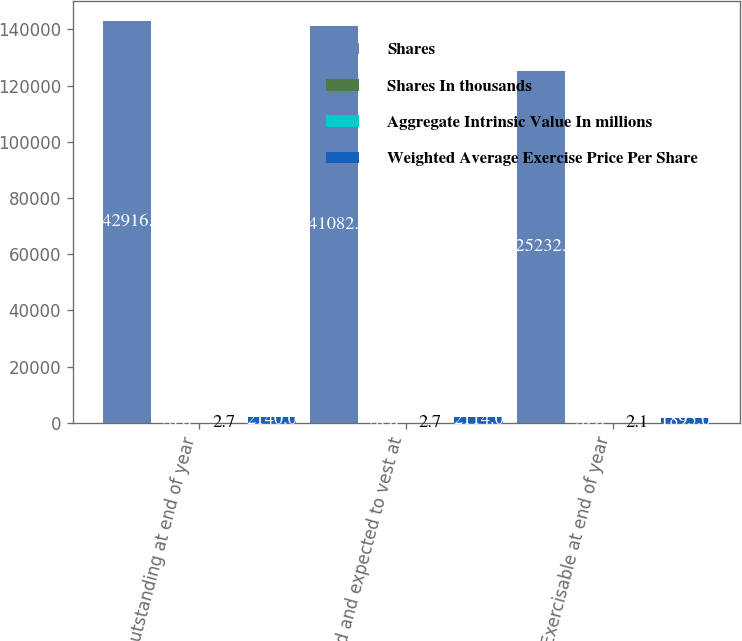Convert chart to OTSL. <chart><loc_0><loc_0><loc_500><loc_500><stacked_bar_chart><ecel><fcel>Outstanding at end of year<fcel>Vested and expected to vest at<fcel>Exercisable at end of year<nl><fcel>Shares<fcel>142916<fcel>141082<fcel>125232<nl><fcel>Shares In thousands<fcel>28<fcel>28<fcel>28<nl><fcel>Aggregate Intrinsic Value In millions<fcel>2.7<fcel>2.7<fcel>2.1<nl><fcel>Weighted Average Exercise Price Per Share<fcel>2140<fcel>2114<fcel>1895<nl></chart> 